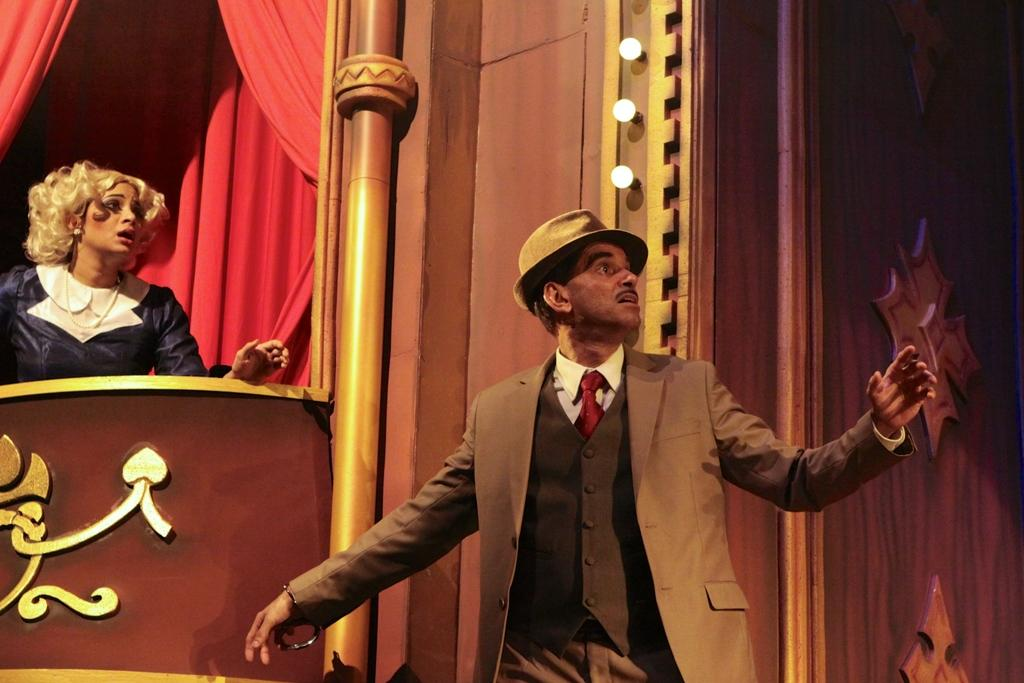How many people are on the stage in the foreground? There are two persons on the stage in the foreground. What can be seen in the background of the image? There are curtains in the background. What is the setting of the image? The image includes a wall, which suggests it is an indoor setting. What is used to illuminate the stage? Lights are present in the image. Can you describe any objects in the image? There are some objects in the image, but their specific nature is not mentioned in the facts. What time of day might the image have been taken? The image may have been taken during the night, as there are lights illuminating the stage. What verse is being recited by the person on the left side of the stage? There is no mention of a verse or any recitation in the image. What type of wheel is visible on the stage? There is no wheel present in the image. 